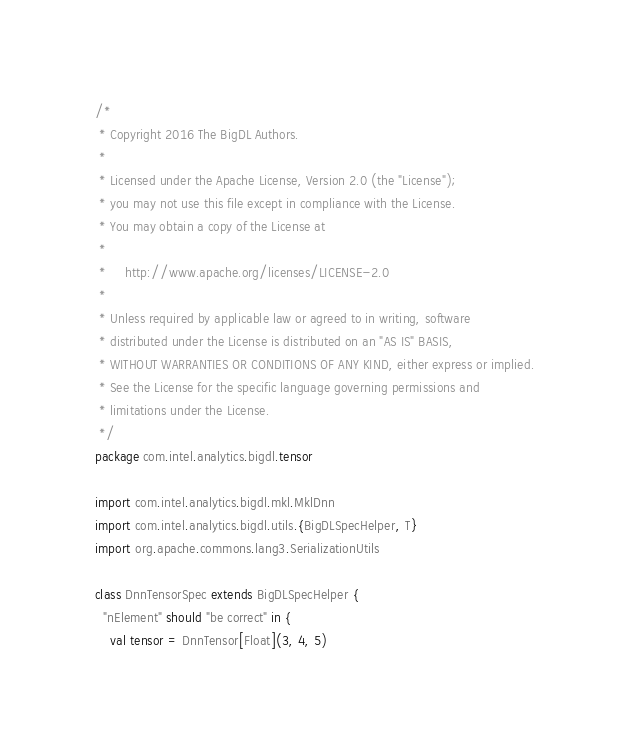<code> <loc_0><loc_0><loc_500><loc_500><_Scala_>/*
 * Copyright 2016 The BigDL Authors.
 *
 * Licensed under the Apache License, Version 2.0 (the "License");
 * you may not use this file except in compliance with the License.
 * You may obtain a copy of the License at
 *
 *     http://www.apache.org/licenses/LICENSE-2.0
 *
 * Unless required by applicable law or agreed to in writing, software
 * distributed under the License is distributed on an "AS IS" BASIS,
 * WITHOUT WARRANTIES OR CONDITIONS OF ANY KIND, either express or implied.
 * See the License for the specific language governing permissions and
 * limitations under the License.
 */
package com.intel.analytics.bigdl.tensor

import com.intel.analytics.bigdl.mkl.MklDnn
import com.intel.analytics.bigdl.utils.{BigDLSpecHelper, T}
import org.apache.commons.lang3.SerializationUtils

class DnnTensorSpec extends BigDLSpecHelper {
  "nElement" should "be correct" in {
    val tensor = DnnTensor[Float](3, 4, 5)</code> 